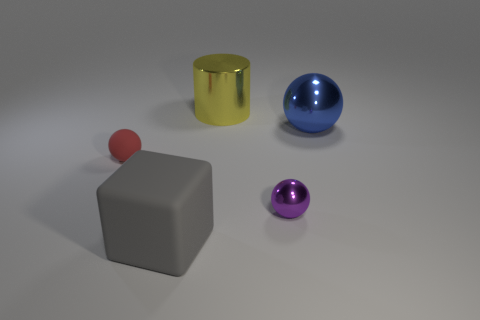Add 1 large cubes. How many objects exist? 6 Subtract all cubes. How many objects are left? 4 Subtract all large green metal cylinders. Subtract all spheres. How many objects are left? 2 Add 1 small metallic things. How many small metallic things are left? 2 Add 3 small metallic blocks. How many small metallic blocks exist? 3 Subtract 1 purple spheres. How many objects are left? 4 